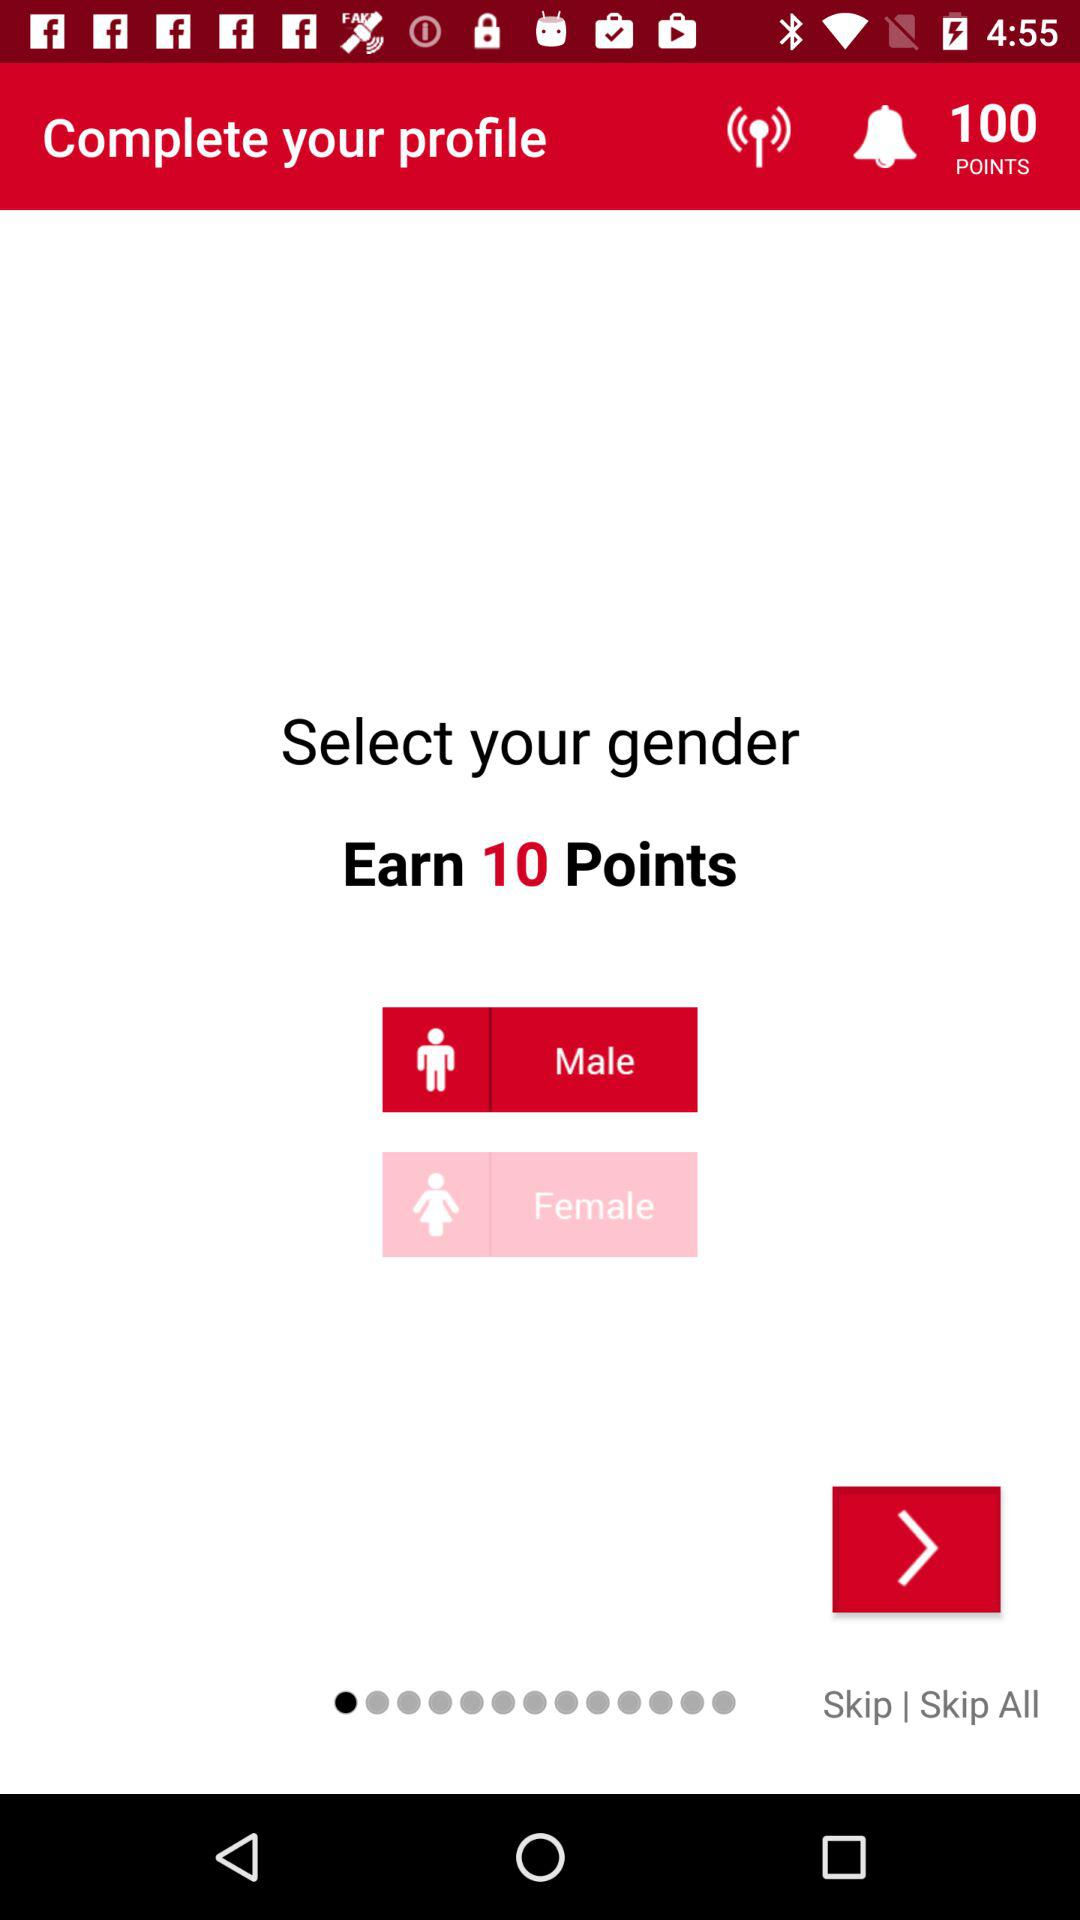How many more points can I earn by selecting a gender?
Answer the question using a single word or phrase. 10 